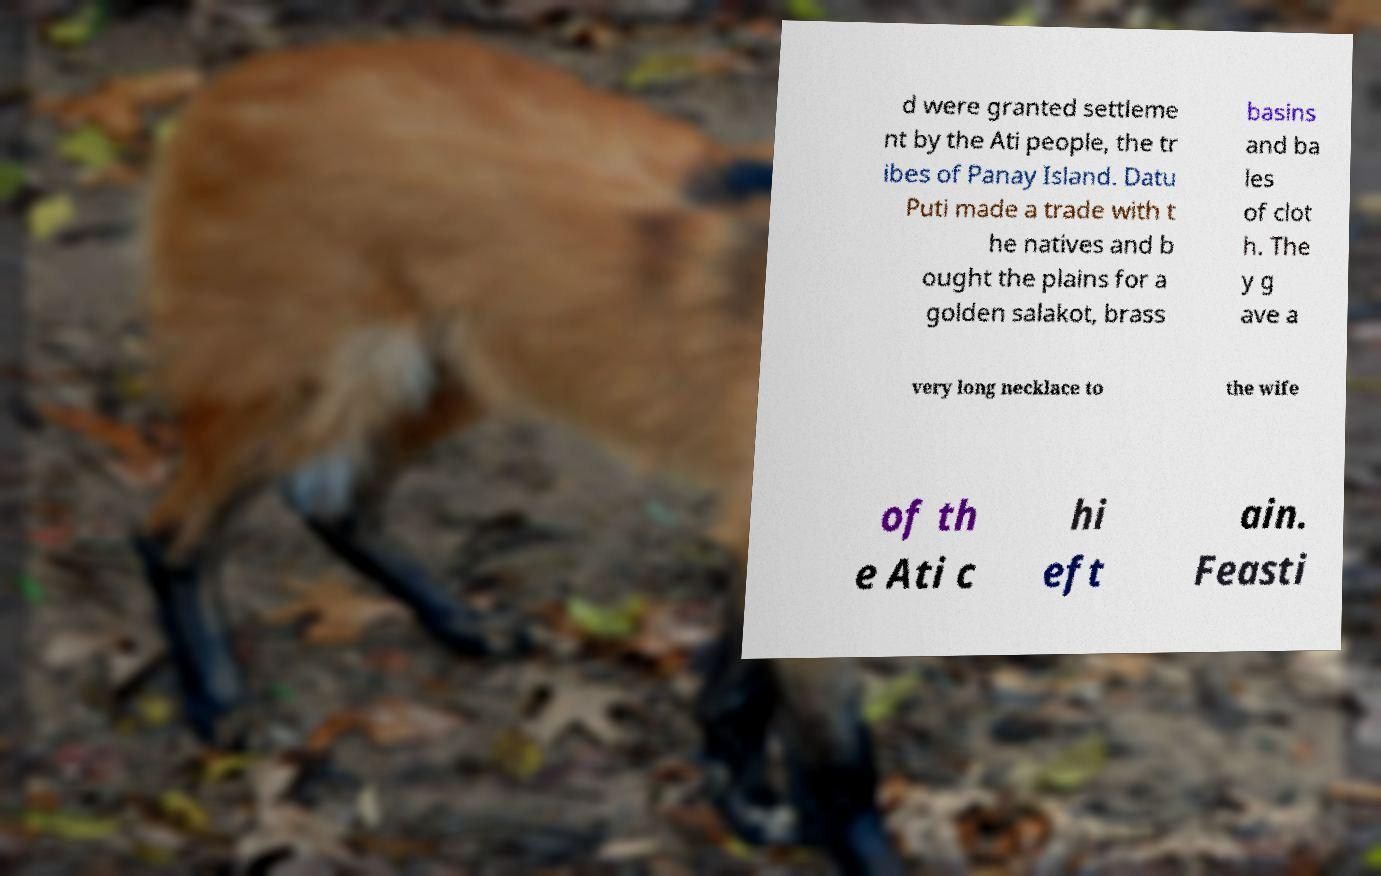Could you assist in decoding the text presented in this image and type it out clearly? d were granted settleme nt by the Ati people, the tr ibes of Panay Island. Datu Puti made a trade with t he natives and b ought the plains for a golden salakot, brass basins and ba les of clot h. The y g ave a very long necklace to the wife of th e Ati c hi eft ain. Feasti 